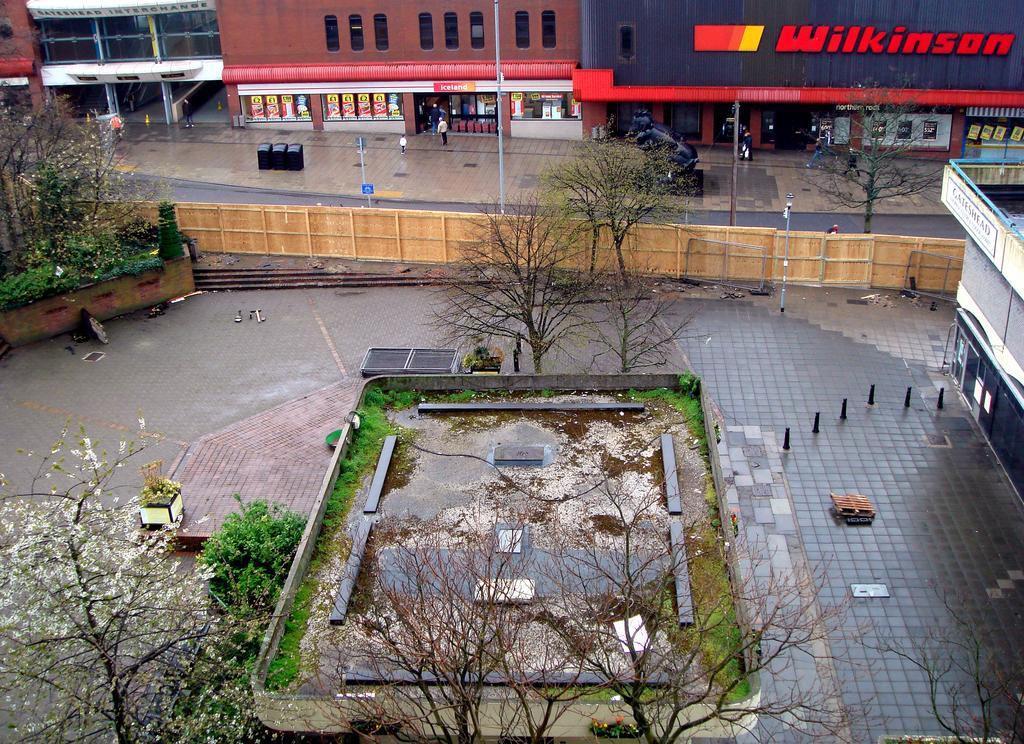Could you give a brief overview of what you see in this image? In this image, we can see trees, plants, walkway, poles, stairs and fence. On the right side and top of the image, we can see buildings and walls. Here we can see the road, walkway, people, poles and posters. 